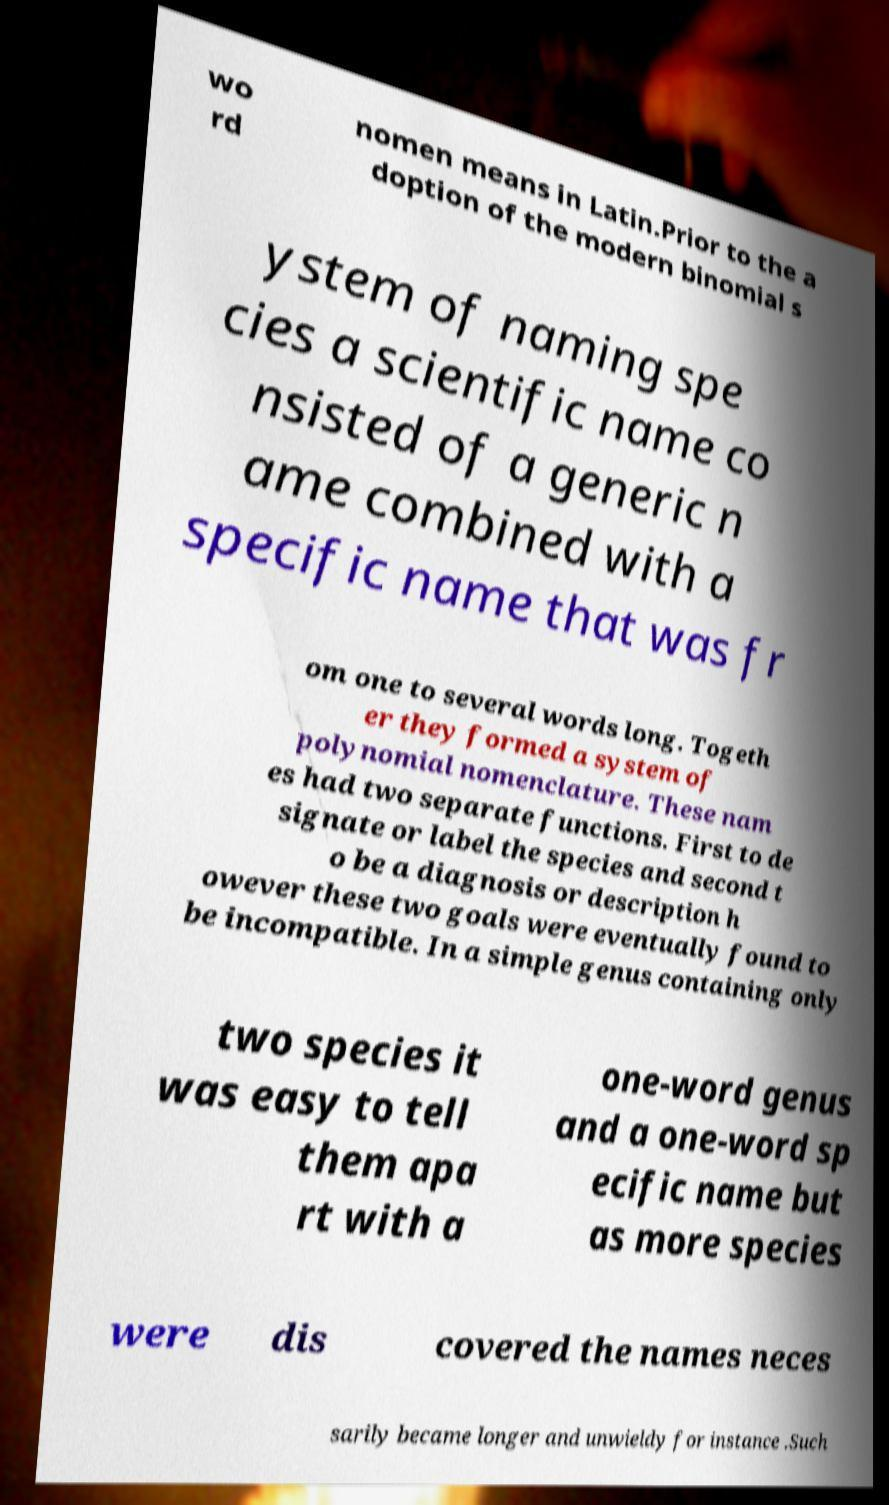There's text embedded in this image that I need extracted. Can you transcribe it verbatim? wo rd nomen means in Latin.Prior to the a doption of the modern binomial s ystem of naming spe cies a scientific name co nsisted of a generic n ame combined with a specific name that was fr om one to several words long. Togeth er they formed a system of polynomial nomenclature. These nam es had two separate functions. First to de signate or label the species and second t o be a diagnosis or description h owever these two goals were eventually found to be incompatible. In a simple genus containing only two species it was easy to tell them apa rt with a one-word genus and a one-word sp ecific name but as more species were dis covered the names neces sarily became longer and unwieldy for instance .Such 